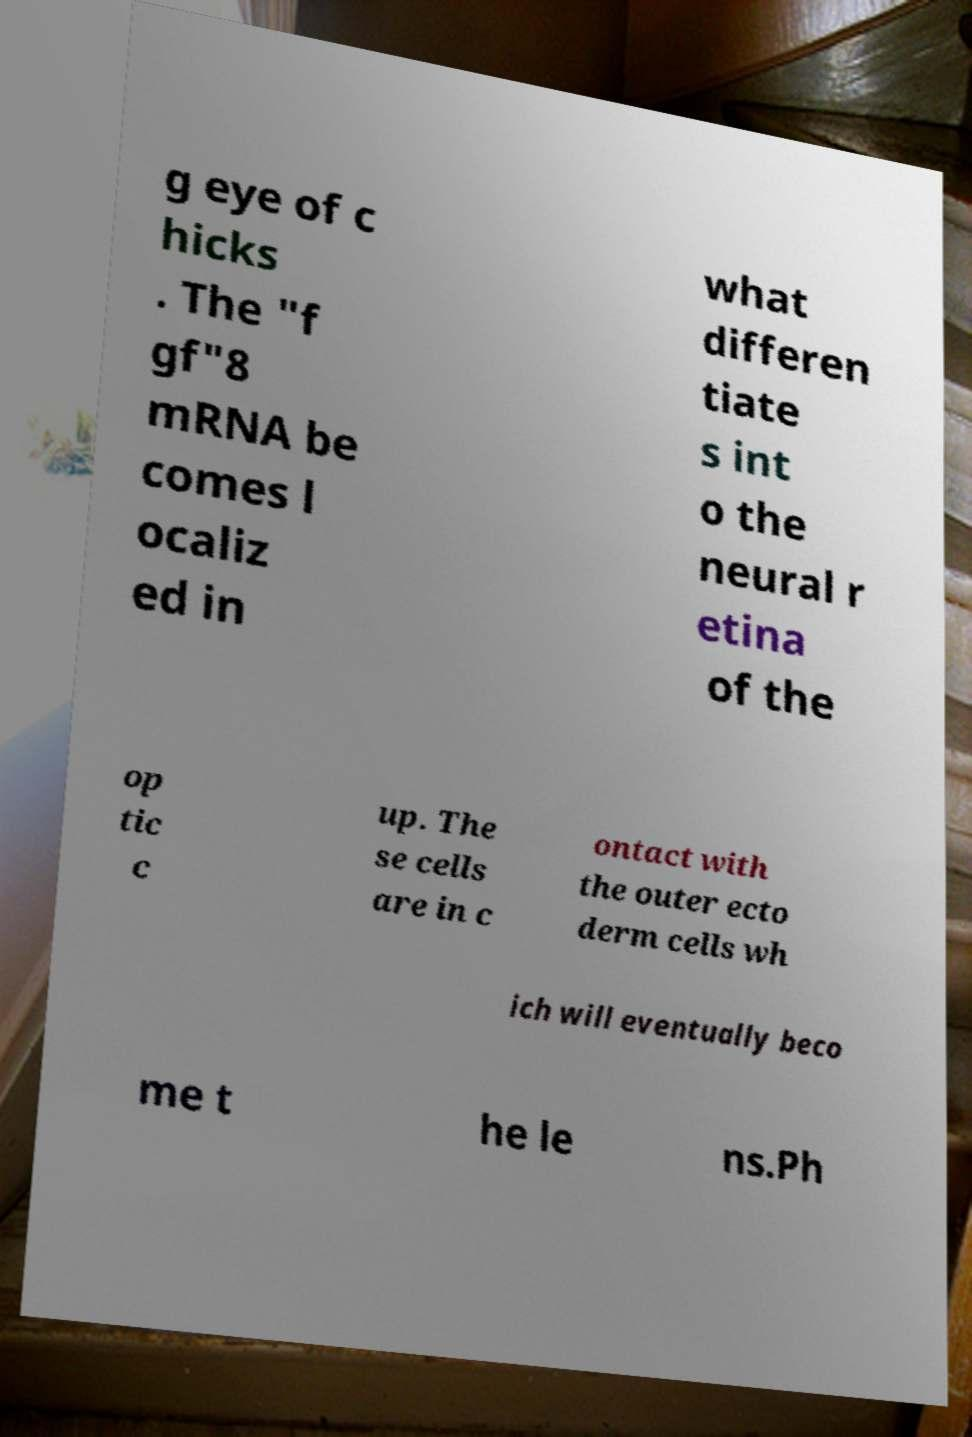I need the written content from this picture converted into text. Can you do that? g eye of c hicks . The "f gf"8 mRNA be comes l ocaliz ed in what differen tiate s int o the neural r etina of the op tic c up. The se cells are in c ontact with the outer ecto derm cells wh ich will eventually beco me t he le ns.Ph 